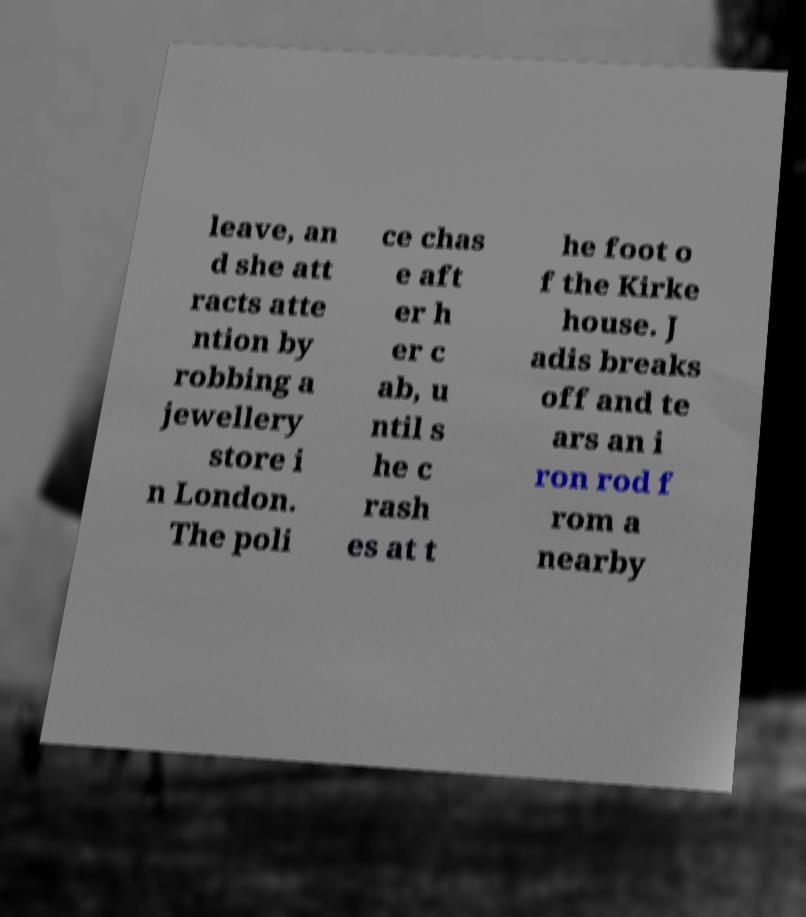What messages or text are displayed in this image? I need them in a readable, typed format. leave, an d she att racts atte ntion by robbing a jewellery store i n London. The poli ce chas e aft er h er c ab, u ntil s he c rash es at t he foot o f the Kirke house. J adis breaks off and te ars an i ron rod f rom a nearby 